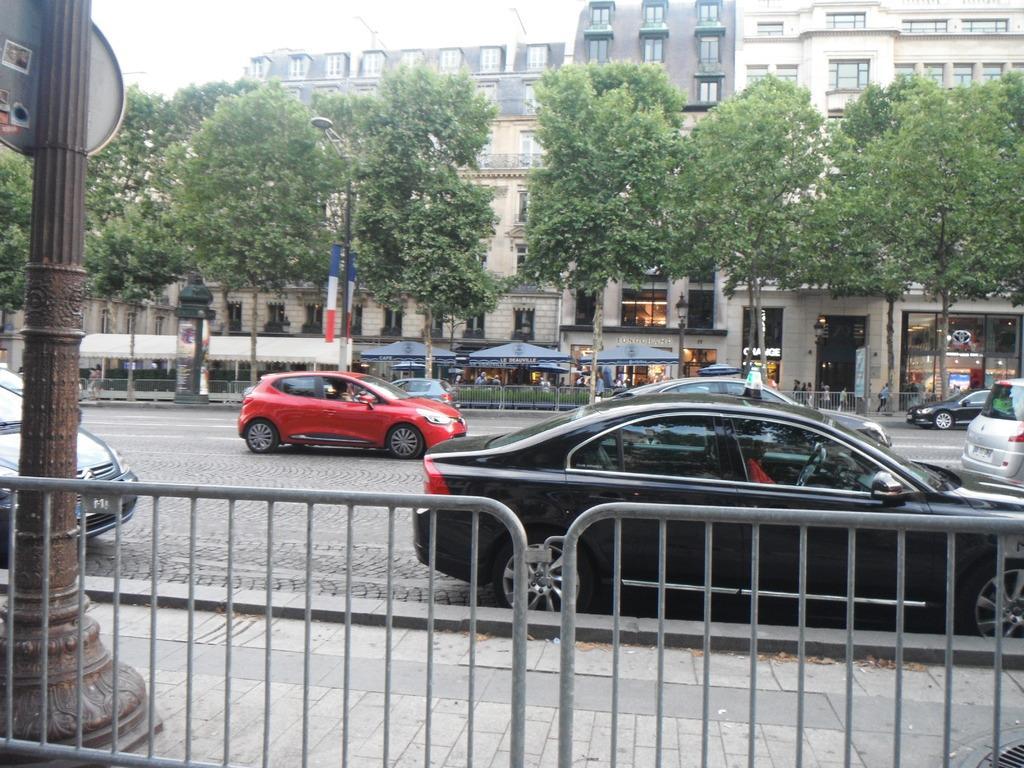Can you describe this image briefly? In the image there are few cars going on the road, on either side of it there is fence, in the back there is building with trees in front of it and people walking on the footpath and above its sky. 